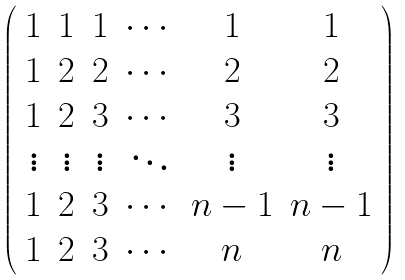<formula> <loc_0><loc_0><loc_500><loc_500>\left ( \begin{array} { c c c c c c } 1 & 1 & 1 & \cdots & 1 & 1 \\ 1 & 2 & 2 & \cdots & 2 & 2 \\ 1 & 2 & 3 & \cdots & 3 & 3 \\ \vdots & \vdots & \vdots & \ddots & \vdots & \vdots \\ 1 & 2 & 3 & \cdots & n - 1 & n - 1 \\ 1 & 2 & 3 & \cdots & n & n \end{array} \right )</formula> 